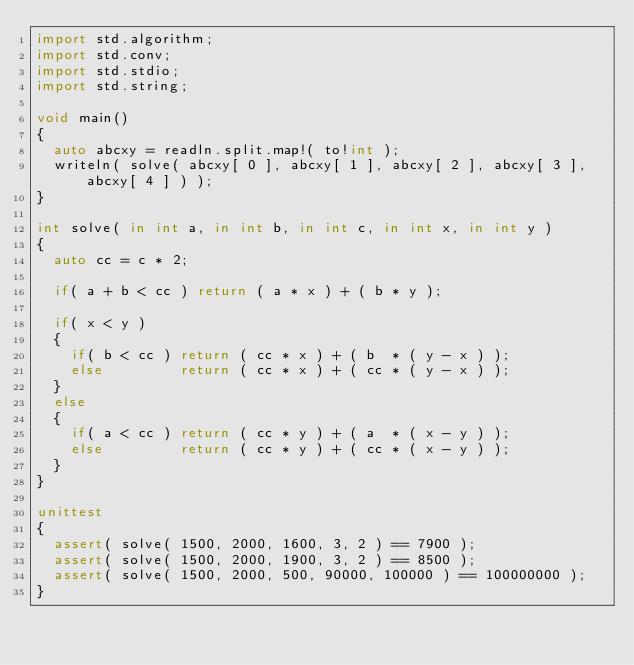<code> <loc_0><loc_0><loc_500><loc_500><_D_>import std.algorithm;
import std.conv;
import std.stdio;
import std.string;

void main()
{
	auto abcxy = readln.split.map!( to!int );
	writeln( solve( abcxy[ 0 ], abcxy[ 1 ], abcxy[ 2 ], abcxy[ 3 ], abcxy[ 4 ] ) );
}

int solve( in int a, in int b, in int c, in int x, in int y )
{
	auto cc = c * 2;
	
	if( a + b < cc ) return ( a * x ) + ( b * y );
	
	if( x < y )
	{
		if( b < cc ) return ( cc * x ) + ( b  * ( y - x ) );
		else         return ( cc * x ) + ( cc * ( y - x ) );
	}
	else
	{
		if( a < cc ) return ( cc * y ) + ( a  * ( x - y ) );
		else         return ( cc * y ) + ( cc * ( x - y ) );
	}
}

unittest
{
	assert( solve( 1500, 2000, 1600, 3, 2 ) == 7900 );
	assert( solve( 1500, 2000, 1900, 3, 2 ) == 8500 );
	assert( solve( 1500, 2000, 500, 90000, 100000 ) == 100000000 );
}
</code> 